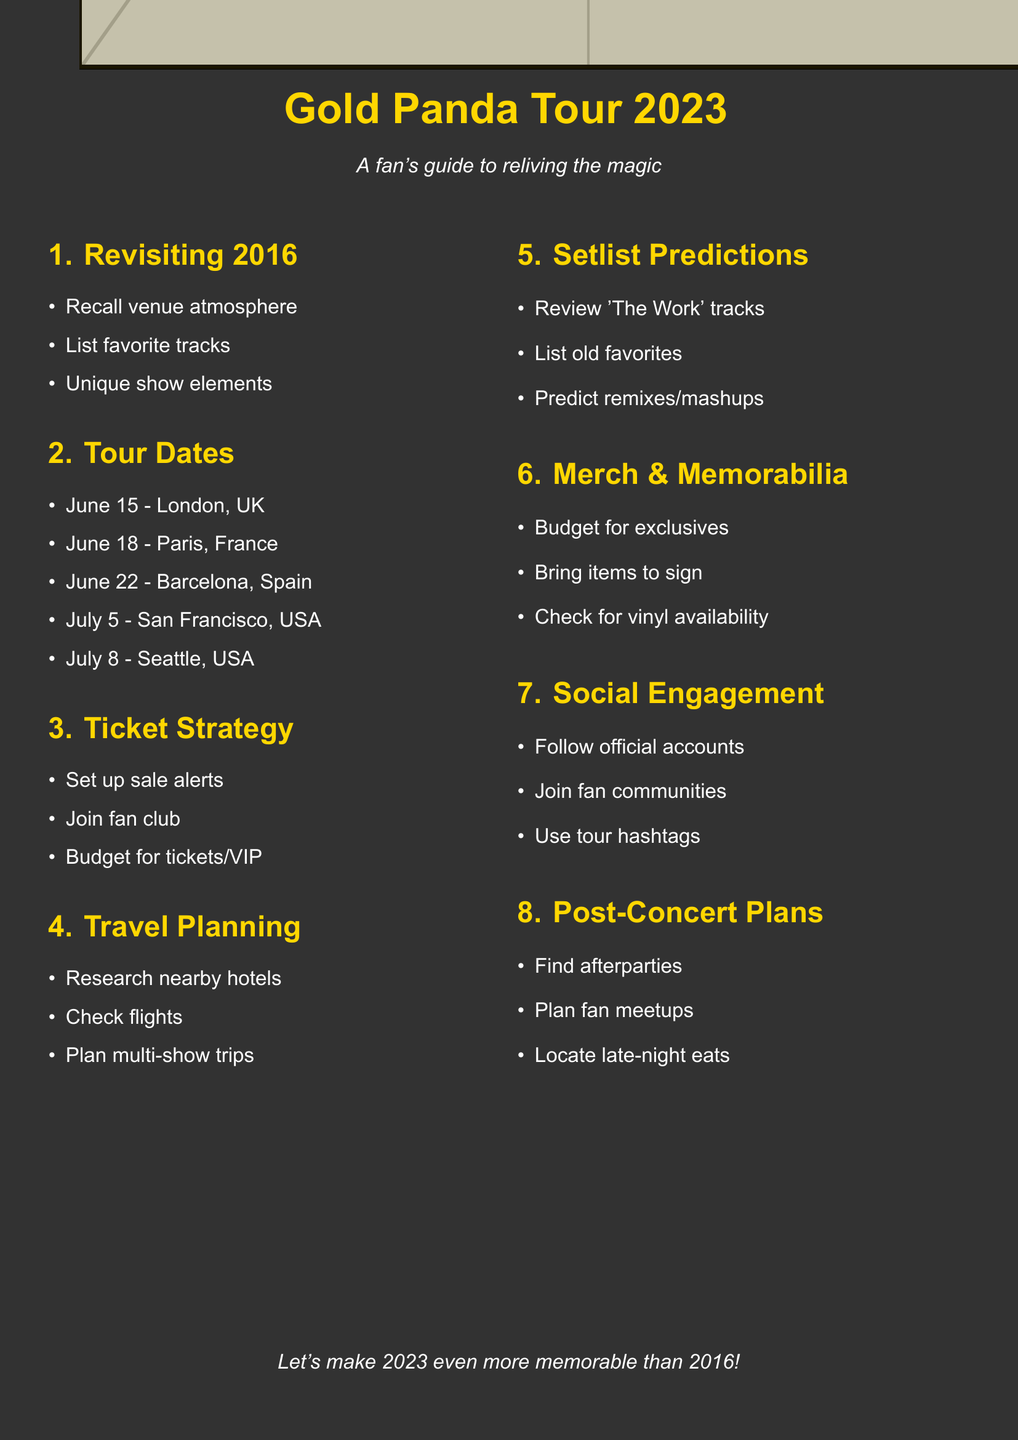What is the title of the first agenda item? The title of the first agenda item is provided as "Revisiting Gold Panda's 2016 Concert Experience".
Answer: Revisiting Gold Panda's 2016 Concert Experience What is the date of the concert in London? The date of the concert in London is listed as "June 15, 2023".
Answer: June 15, 2023 Which city will Gold Panda perform in on July 8, 2023? The document specifies that Gold Panda will perform in Seattle, USA, on that date.
Answer: Seattle, USA What should fans do to secure tickets? Fans are advised to "Set up alerts for ticket sale dates".
Answer: Set up alerts for ticket sale dates What album's tracks should fans review for setlist predictions? The document mentions "tracks from the latest album 'The Work'" as a point for predictions.
Answer: The Work What are fans encouraged to do for social engagement? Fans are encouraged to "Follow Gold Panda's official accounts on Instagram and Twitter".
Answer: Follow Gold Panda's official accounts on Instagram and Twitter How many major areas are covered in the document? The document outlines eight major areas related to the tour planning.
Answer: Eight What is the purpose of the planning document? The document is meant to serve as a guide for fans in reliving the magic of Gold Panda's concerts.
Answer: A fan's guide to reliving the magic 